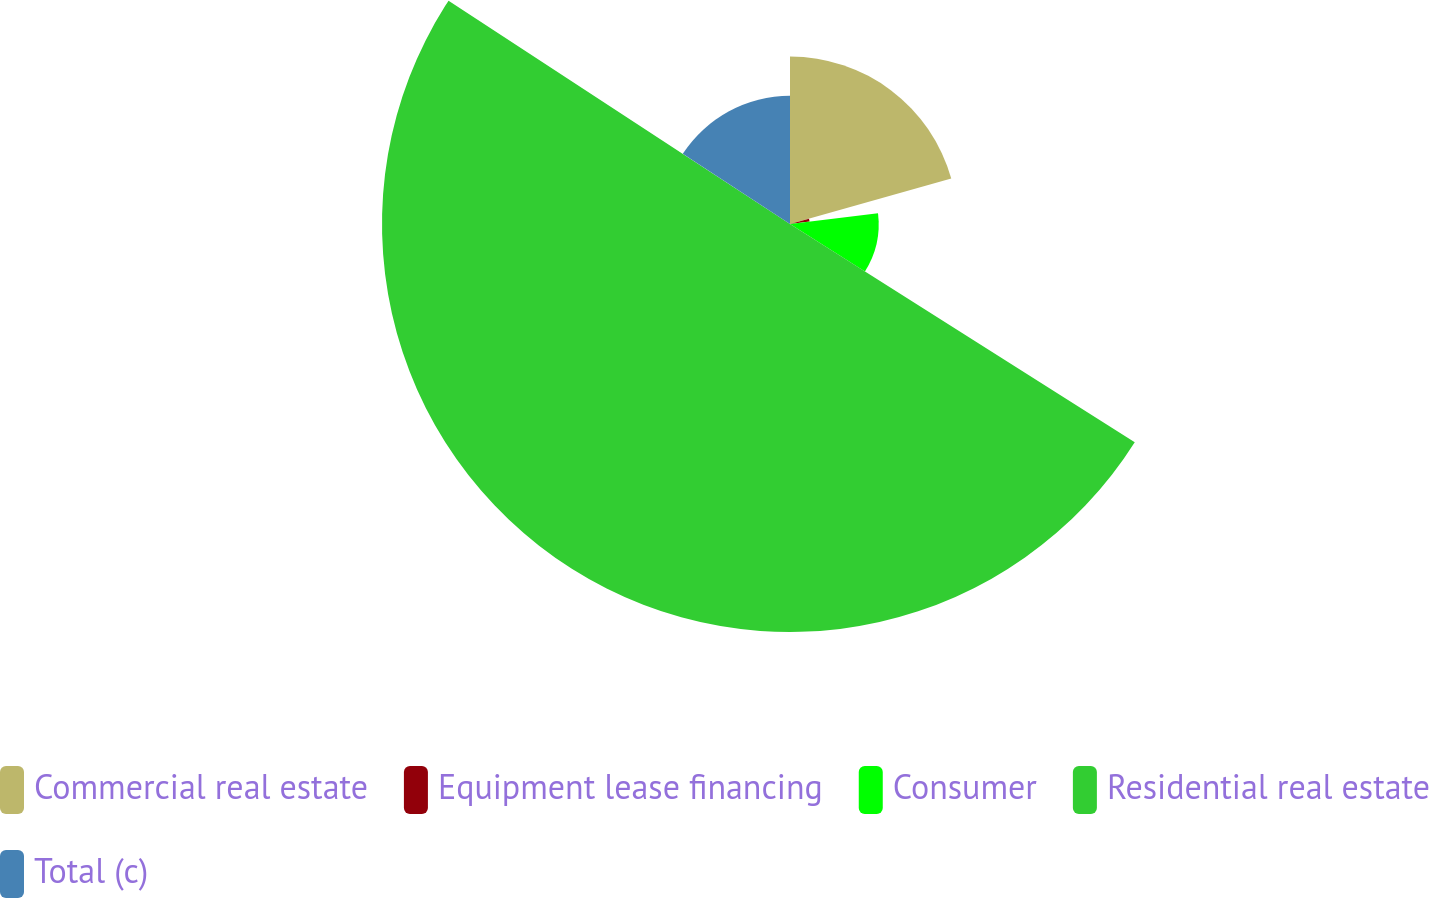Convert chart. <chart><loc_0><loc_0><loc_500><loc_500><pie_chart><fcel>Commercial real estate<fcel>Equipment lease financing<fcel>Consumer<fcel>Residential real estate<fcel>Total (c)<nl><fcel>20.63%<fcel>2.43%<fcel>10.92%<fcel>50.24%<fcel>15.78%<nl></chart> 